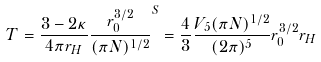<formula> <loc_0><loc_0><loc_500><loc_500>T = \frac { 3 - 2 \kappa } { 4 \pi r _ { H } } \frac { r _ { 0 } ^ { 3 / 2 } } { ( \pi N ) ^ { 1 / 2 } } ^ { S } = \frac { 4 } { 3 } \frac { V _ { 5 } ( \pi N ) ^ { 1 / 2 } } { ( 2 \pi ) ^ { 5 } } r _ { 0 } ^ { 3 / 2 } r _ { H }</formula> 